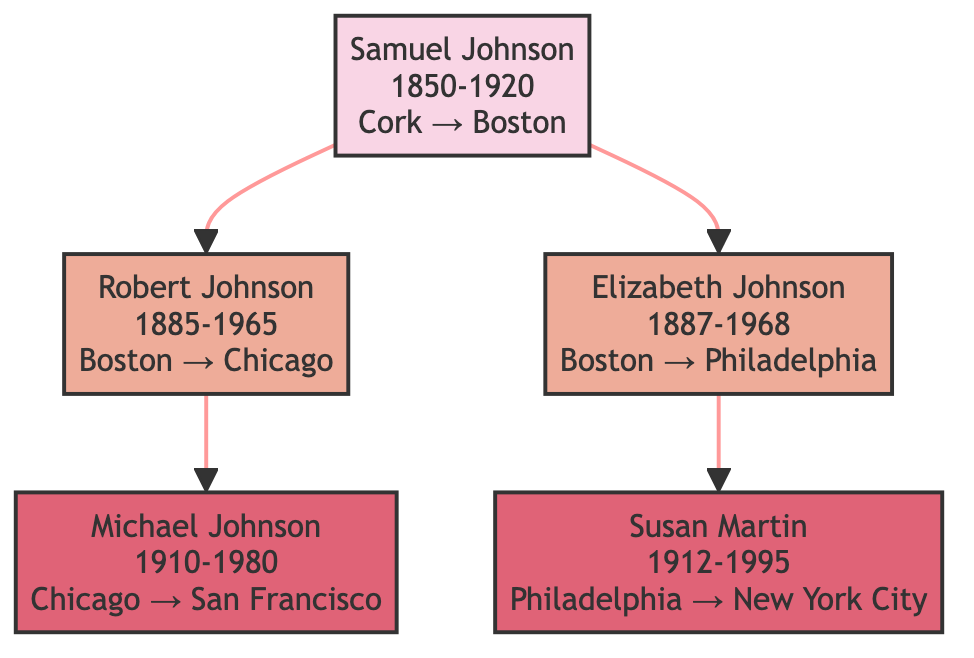What is the birth year of Samuel Johnson? By examining the diagram, Samuel Johnson is labeled with "1850" next to his name, indicating this is his birth year.
Answer: 1850 Which locations did Robert Johnson live in? The diagram shows two locations linked to Robert Johnson: "Boston, USA" and "Chicago, USA." These are noted next to his name in the diagram.
Answer: Boston, USA; Chicago, USA How long did Elizabeth Johnson live in Philadelphia? The diagram indicates that Elizabeth Johnson lived in Philadelphia from "1910" until her death in "1968." Counting the years from 1910 to 1968, this equals 58 years.
Answer: 58 years Which generation migrated to San Francisco? The diagram shows that Michael Johnson, who is in the third generation, is connected to San Francisco in the "location" portion next to his name.
Answer: Third generation What is the migration reason for Samuel Johnson? Samuel Johnson's section in the diagram states "Economic opportunity" as his reason for migrating from Cork, Ireland to Boston, USA.
Answer: Economic opportunity Which city did Susan Martin relocate to after Philadelphia? The diagram shows Susan Martin (née Johnson) transitioned from "Philadelphia, USA" to "New York City, USA," indicating her subsequent location.
Answer: New York City, USA What is the total number of migrations represented in the diagram? The diagram has connections indicating migrations, with each generation showing distinct movements. Samuel Johnson moved once, each next generation features two migrations, resulting in a total of four migrations.
Answer: 4 During which years did Michael Johnson live in Chicago? According to the diagram, Michael Johnson's timeline indicates he lived in Chicago from "1910" to "1935," which can be directly seen next to his name.
Answer: 1910-1935 Which migration reason is associated with Susan Martin? The diagram lists "Job relocation" next to Susan Martin’s name, indicating the rationale for her moving from Philadelphia to New York City.
Answer: Job relocation 